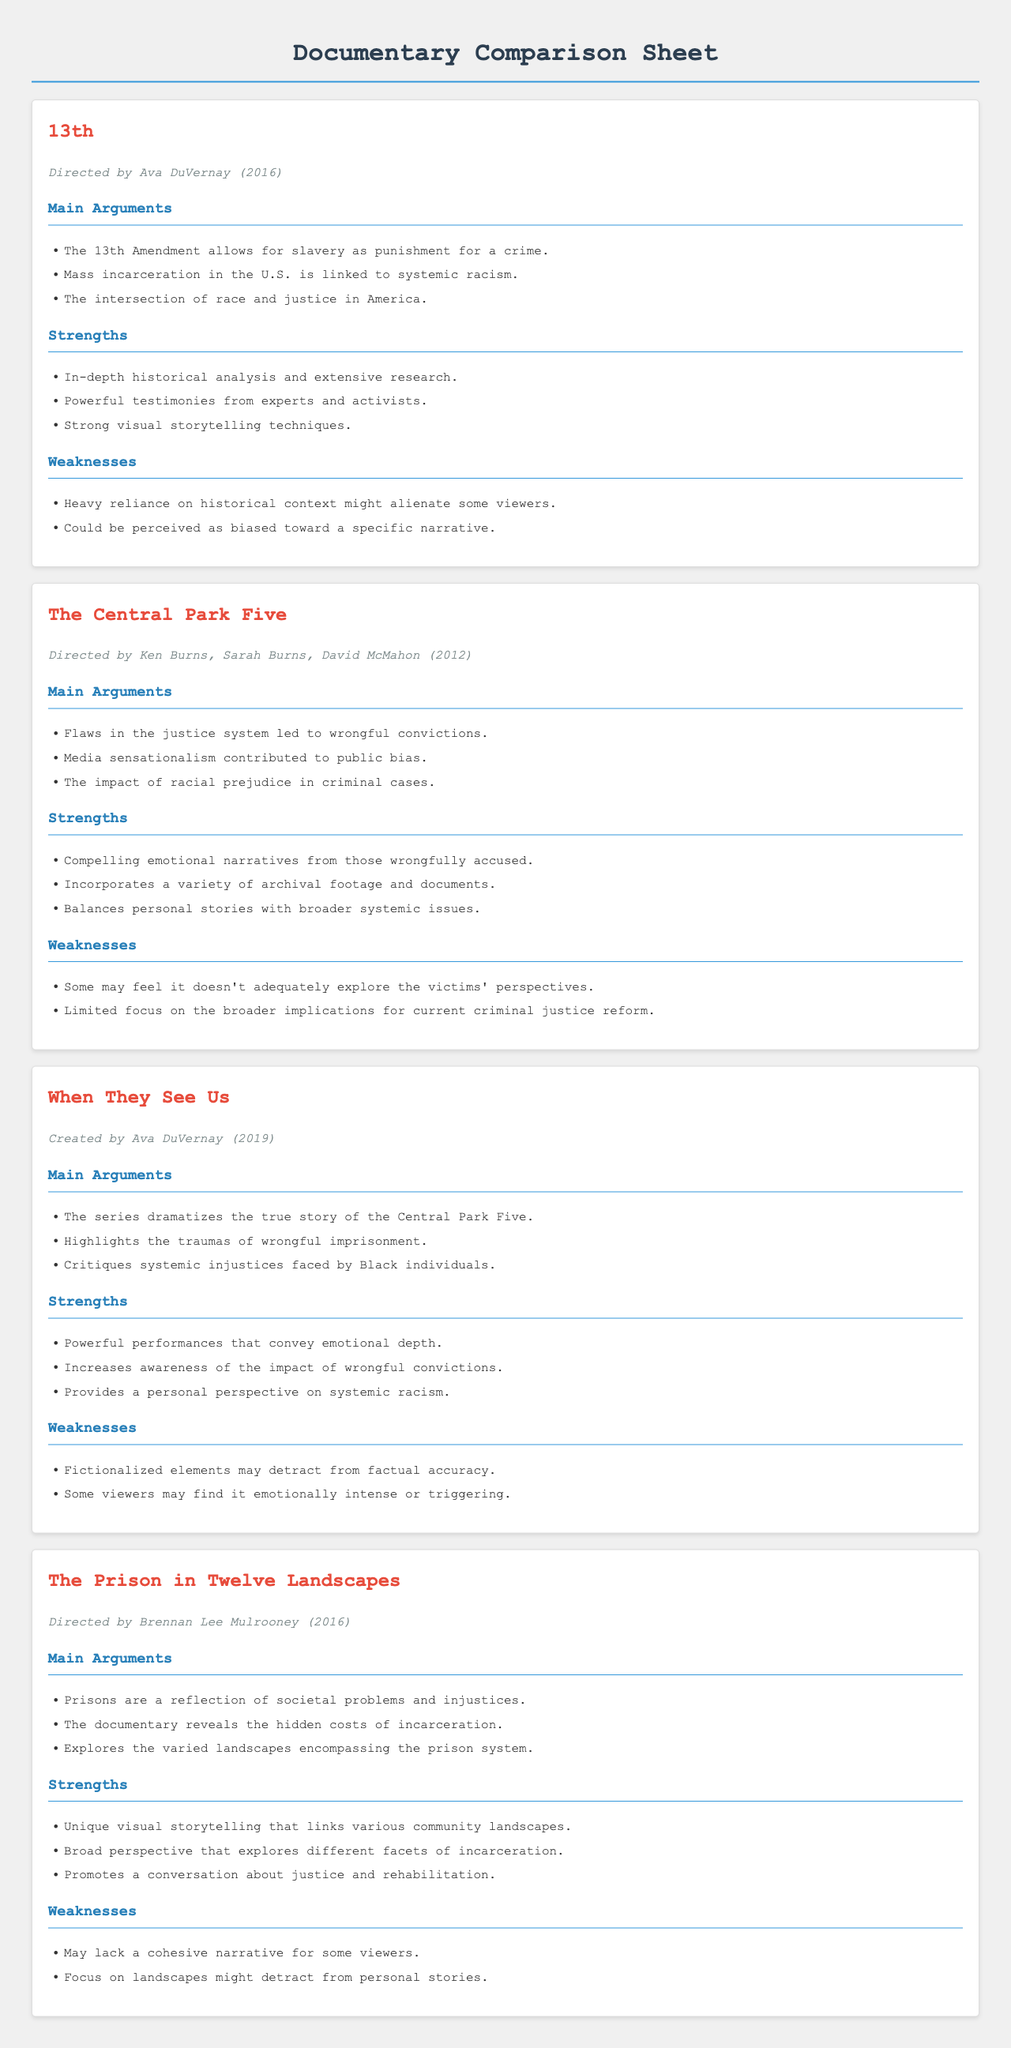what is the title of the documentary directed by Ava DuVernay in 2016? The title is mentioned at the beginning of the documentary section along with the director's name and year.
Answer: 13th who directed "The Central Park Five"? The director's names are listed in each documentary section under the title and year of release.
Answer: Ken Burns, Sarah Burns, David McMahon what is one main argument of "When They See Us"? The main arguments are listed in a section specifically for each documentary. One of the arguments can be selected from that list.
Answer: Highlights the traumas of wrongful imprisonment name one strength of "The Prison in Twelve Landscapes." Strengths are provided as a list in the corresponding section for each documentary.
Answer: Unique visual storytelling that links various community landscapes what year was "The Central Park Five" released? The year is included in the documentary information as part of the heading section.
Answer: 2012 how many documentaries have been directed by Ava DuVernay? A count can be made from the sections, listing the documentaries she directed.
Answer: 2 what is one weakness identified in "13th"? Weaknesses are detailed in their specific section, highlighting challenges faced by each documentary.
Answer: Heavy reliance on historical context might alienate some viewers which documentary includes compelling emotional narratives? This information is highlighted in the strengths section for "The Central Park Five."
Answer: The Central Park Five what aspect of society does "The Prison in Twelve Landscapes" focus on? The main arguments outline the central themes of each documentary. This documentary highlights societal problems.
Answer: Societal problems and injustices 